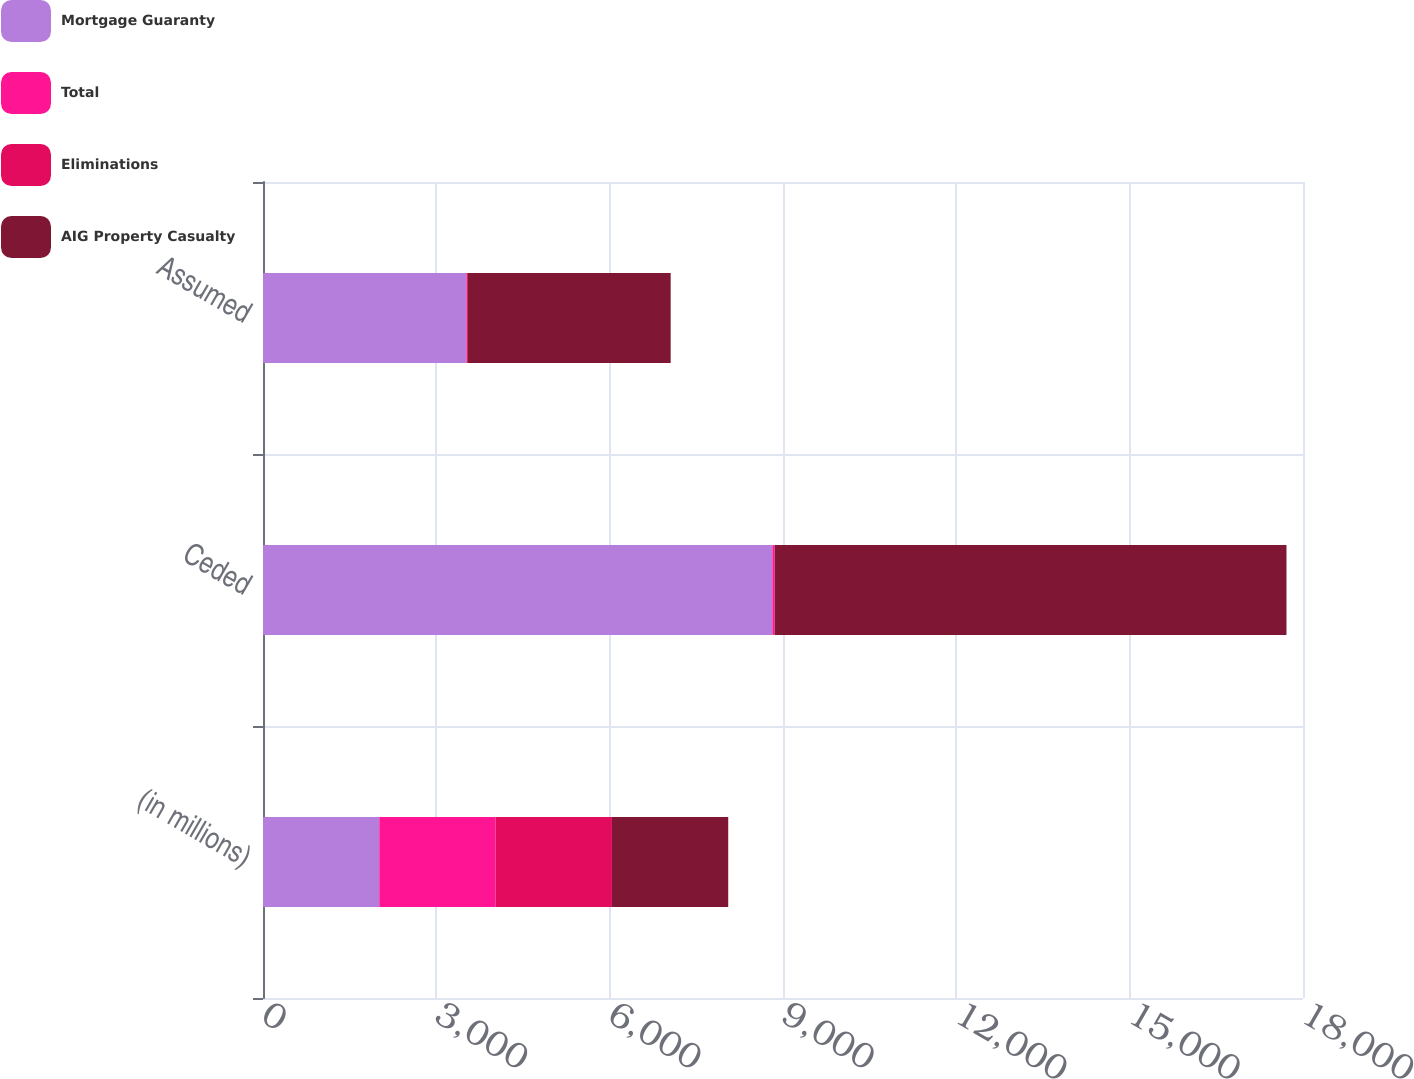<chart> <loc_0><loc_0><loc_500><loc_500><stacked_bar_chart><ecel><fcel>(in millions)<fcel>Ceded<fcel>Assumed<nl><fcel>Mortgage Guaranty<fcel>2013<fcel>8816<fcel>3521<nl><fcel>Total<fcel>2013<fcel>38<fcel>7<nl><fcel>Eliminations<fcel>2013<fcel>3<fcel>18<nl><fcel>AIG Property Casualty<fcel>2013<fcel>8857<fcel>3510<nl></chart> 